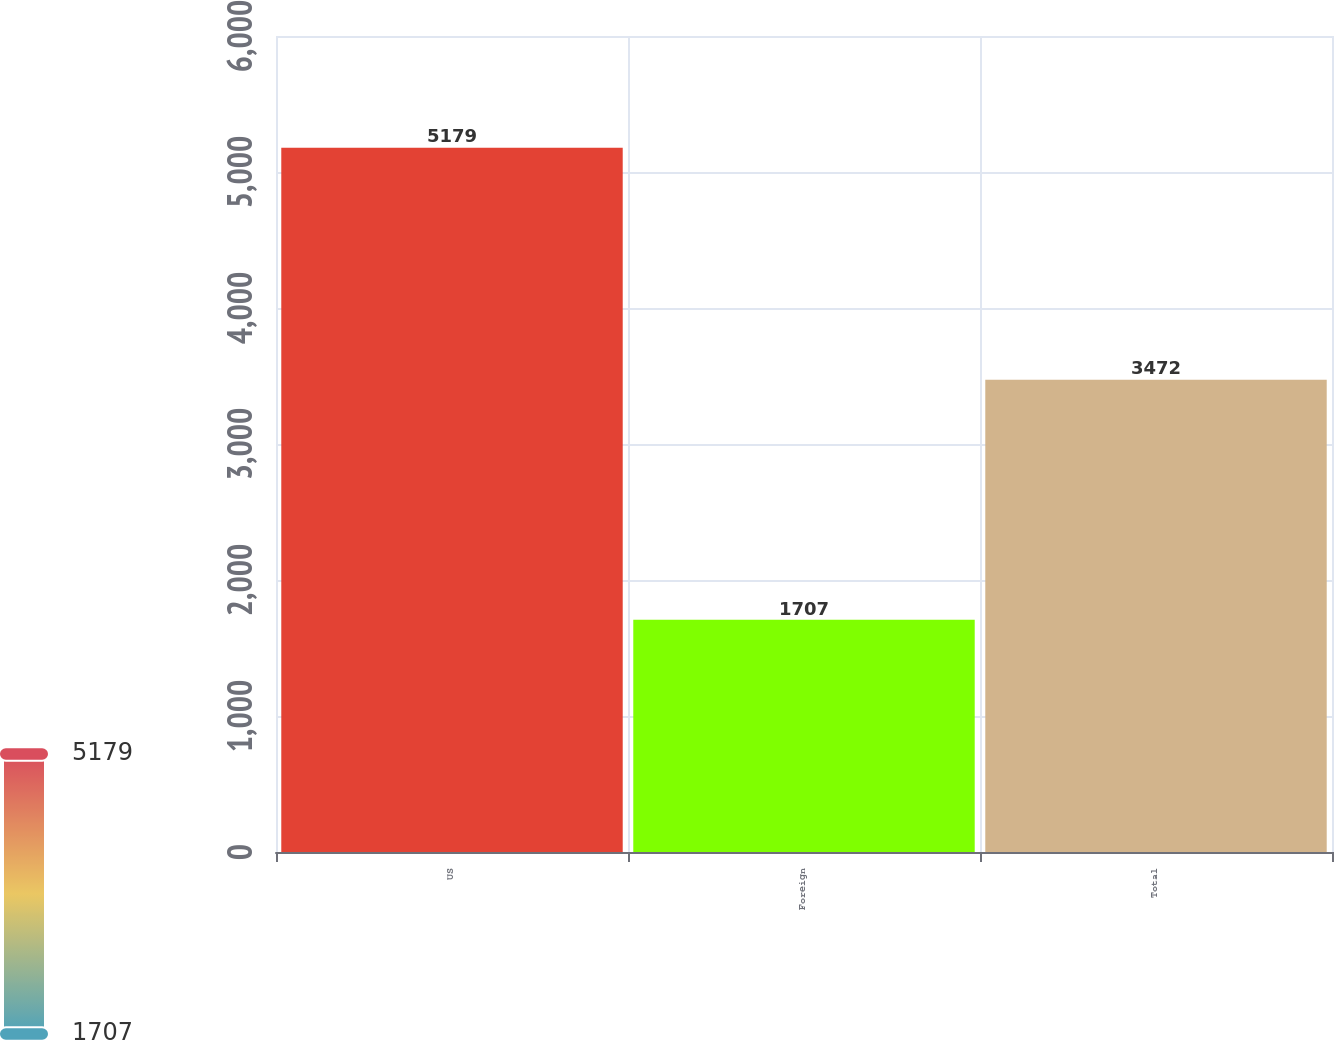<chart> <loc_0><loc_0><loc_500><loc_500><bar_chart><fcel>US<fcel>Foreign<fcel>Total<nl><fcel>5179<fcel>1707<fcel>3472<nl></chart> 